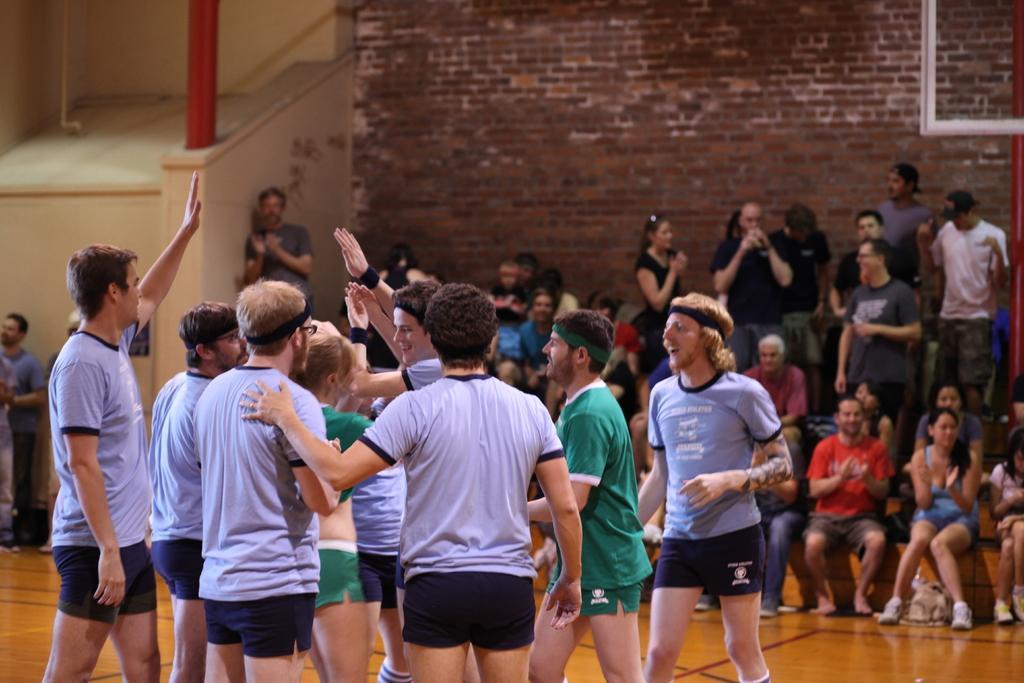Could you give a brief overview of what you see in this image? In this image, we can see a group of people are standing. Few are raising their hand. Background we can see a group of people. Few are sitting and other are standing. Here we can see a brick wall, pillar and few objects. At the bottom, we can see the floor. 